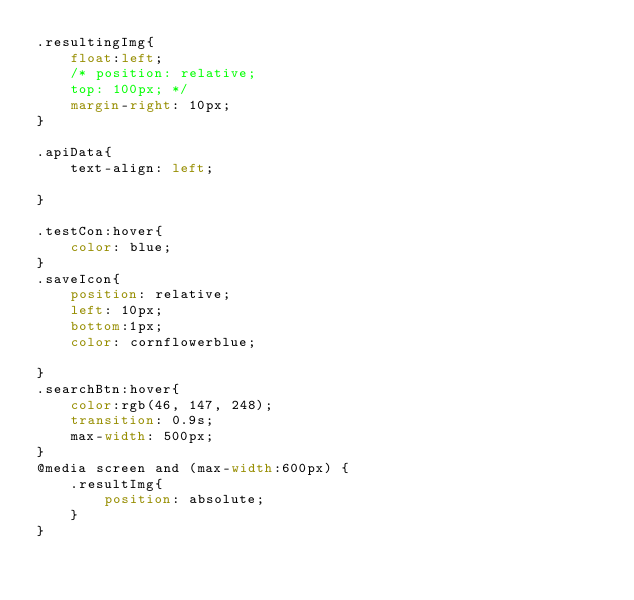<code> <loc_0><loc_0><loc_500><loc_500><_CSS_>.resultingImg{
    float:left;
    /* position: relative;
    top: 100px; */
    margin-right: 10px;
}

.apiData{
    text-align: left;
    
}

.testCon:hover{
    color: blue;
}
.saveIcon{
    position: relative;
    left: 10px;
    bottom:1px;
    color: cornflowerblue;
    
}
.searchBtn:hover{
    color:rgb(46, 147, 248);
    transition: 0.9s;
    max-width: 500px;
}
@media screen and (max-width:600px) {
    .resultImg{
        position: absolute;
    }
}
</code> 